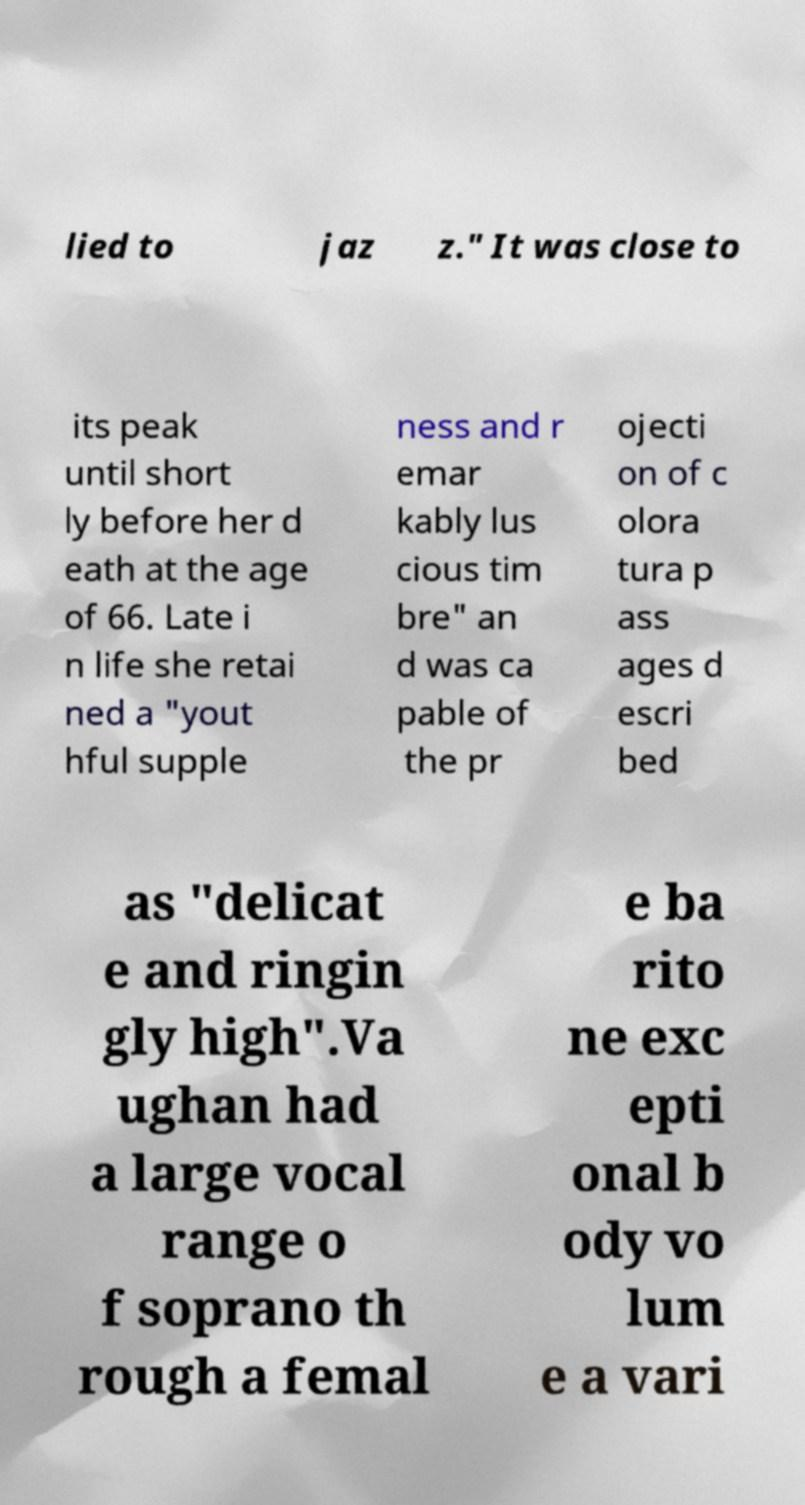What messages or text are displayed in this image? I need them in a readable, typed format. lied to jaz z." It was close to its peak until short ly before her d eath at the age of 66. Late i n life she retai ned a "yout hful supple ness and r emar kably lus cious tim bre" an d was ca pable of the pr ojecti on of c olora tura p ass ages d escri bed as "delicat e and ringin gly high".Va ughan had a large vocal range o f soprano th rough a femal e ba rito ne exc epti onal b ody vo lum e a vari 